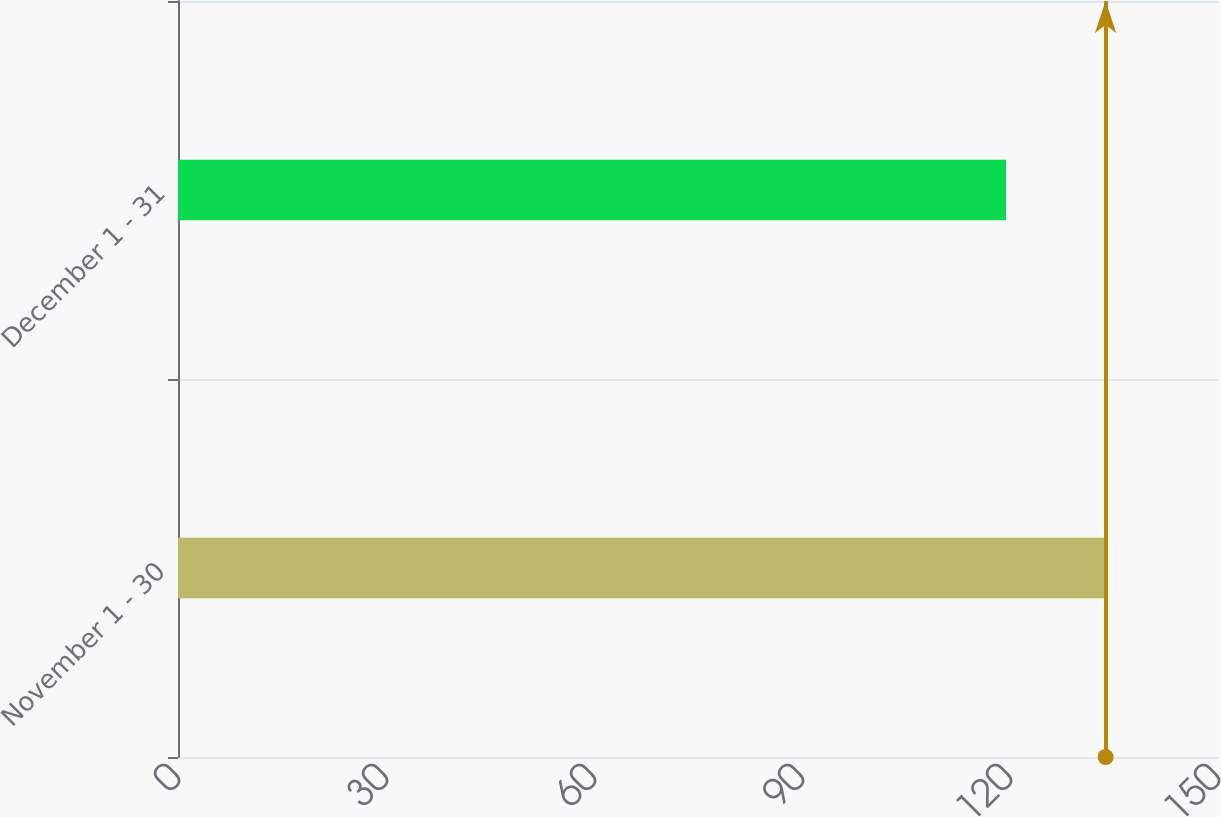<chart> <loc_0><loc_0><loc_500><loc_500><bar_chart><fcel>November 1 - 30<fcel>December 1 - 31<nl><fcel>133.79<fcel>119.43<nl></chart> 